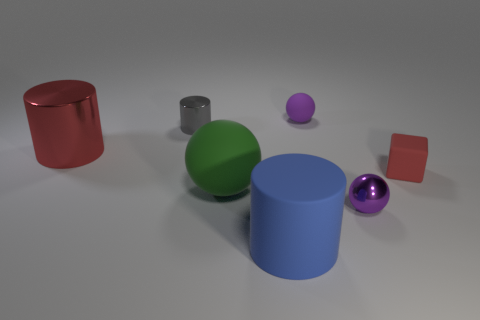Add 3 green things. How many objects exist? 10 Subtract all spheres. How many objects are left? 4 Subtract all big green matte things. Subtract all blue matte cylinders. How many objects are left? 5 Add 6 large blue rubber cylinders. How many large blue rubber cylinders are left? 7 Add 3 matte cylinders. How many matte cylinders exist? 4 Subtract 0 brown cubes. How many objects are left? 7 